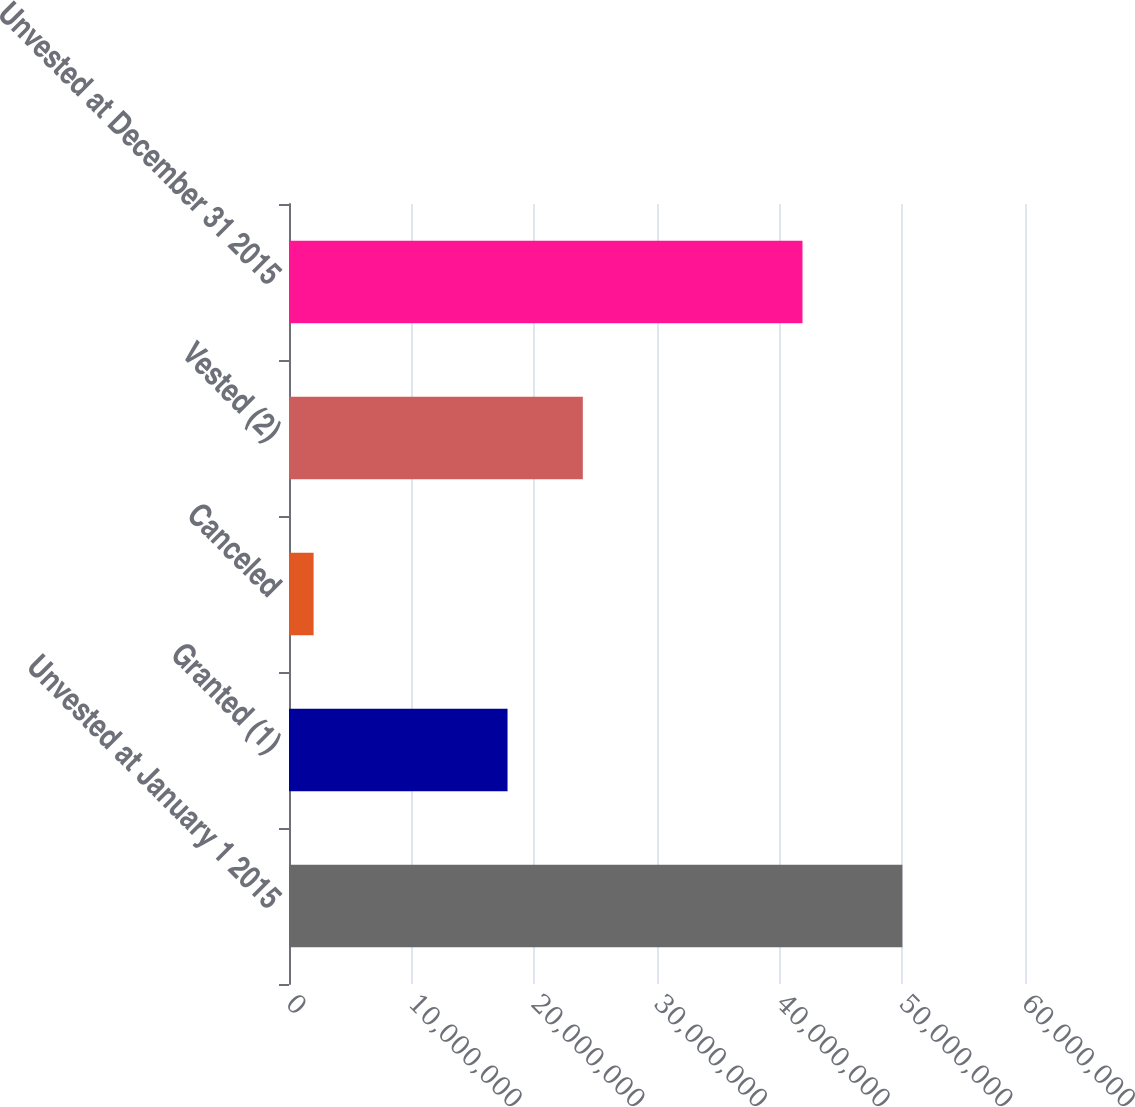Convert chart to OTSL. <chart><loc_0><loc_0><loc_500><loc_500><bar_chart><fcel>Unvested at January 1 2015<fcel>Granted (1)<fcel>Canceled<fcel>Vested (2)<fcel>Unvested at December 31 2015<nl><fcel>5.00044e+07<fcel>1.78155e+07<fcel>2.00588e+06<fcel>2.39537e+07<fcel>4.18603e+07<nl></chart> 